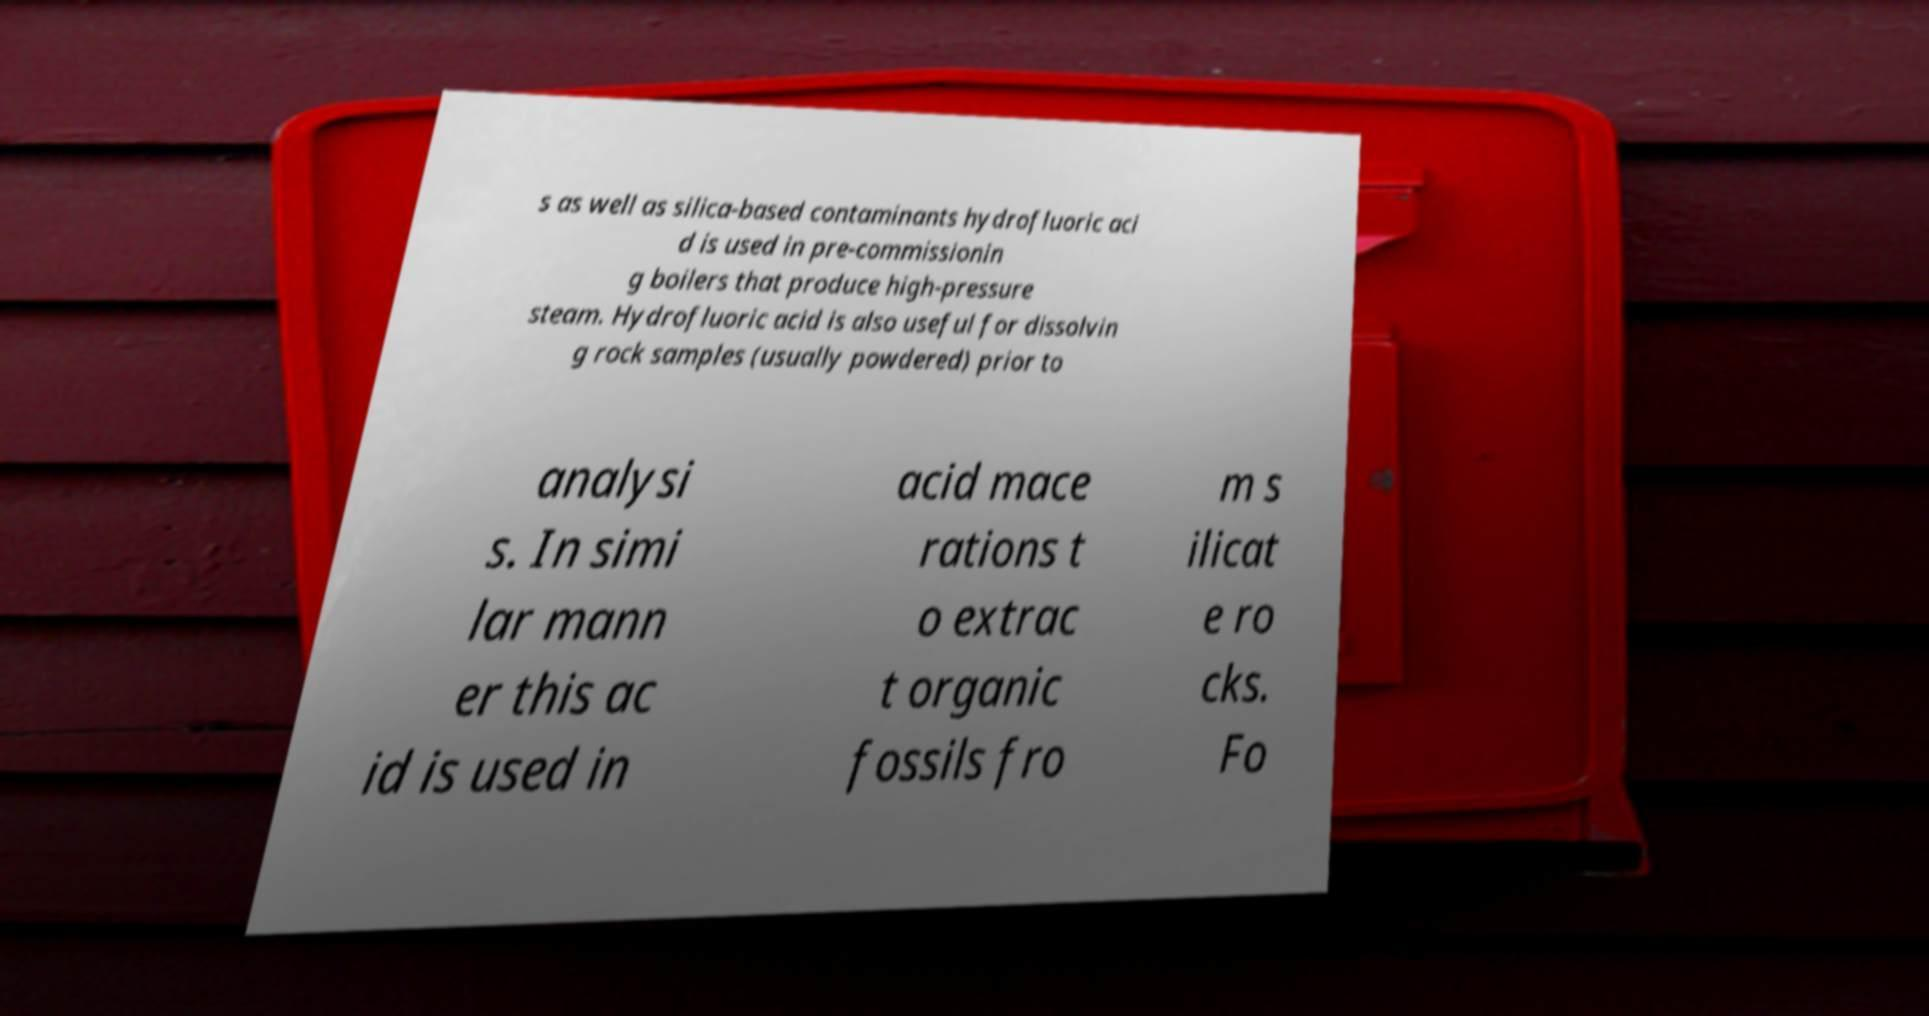I need the written content from this picture converted into text. Can you do that? s as well as silica-based contaminants hydrofluoric aci d is used in pre-commissionin g boilers that produce high-pressure steam. Hydrofluoric acid is also useful for dissolvin g rock samples (usually powdered) prior to analysi s. In simi lar mann er this ac id is used in acid mace rations t o extrac t organic fossils fro m s ilicat e ro cks. Fo 